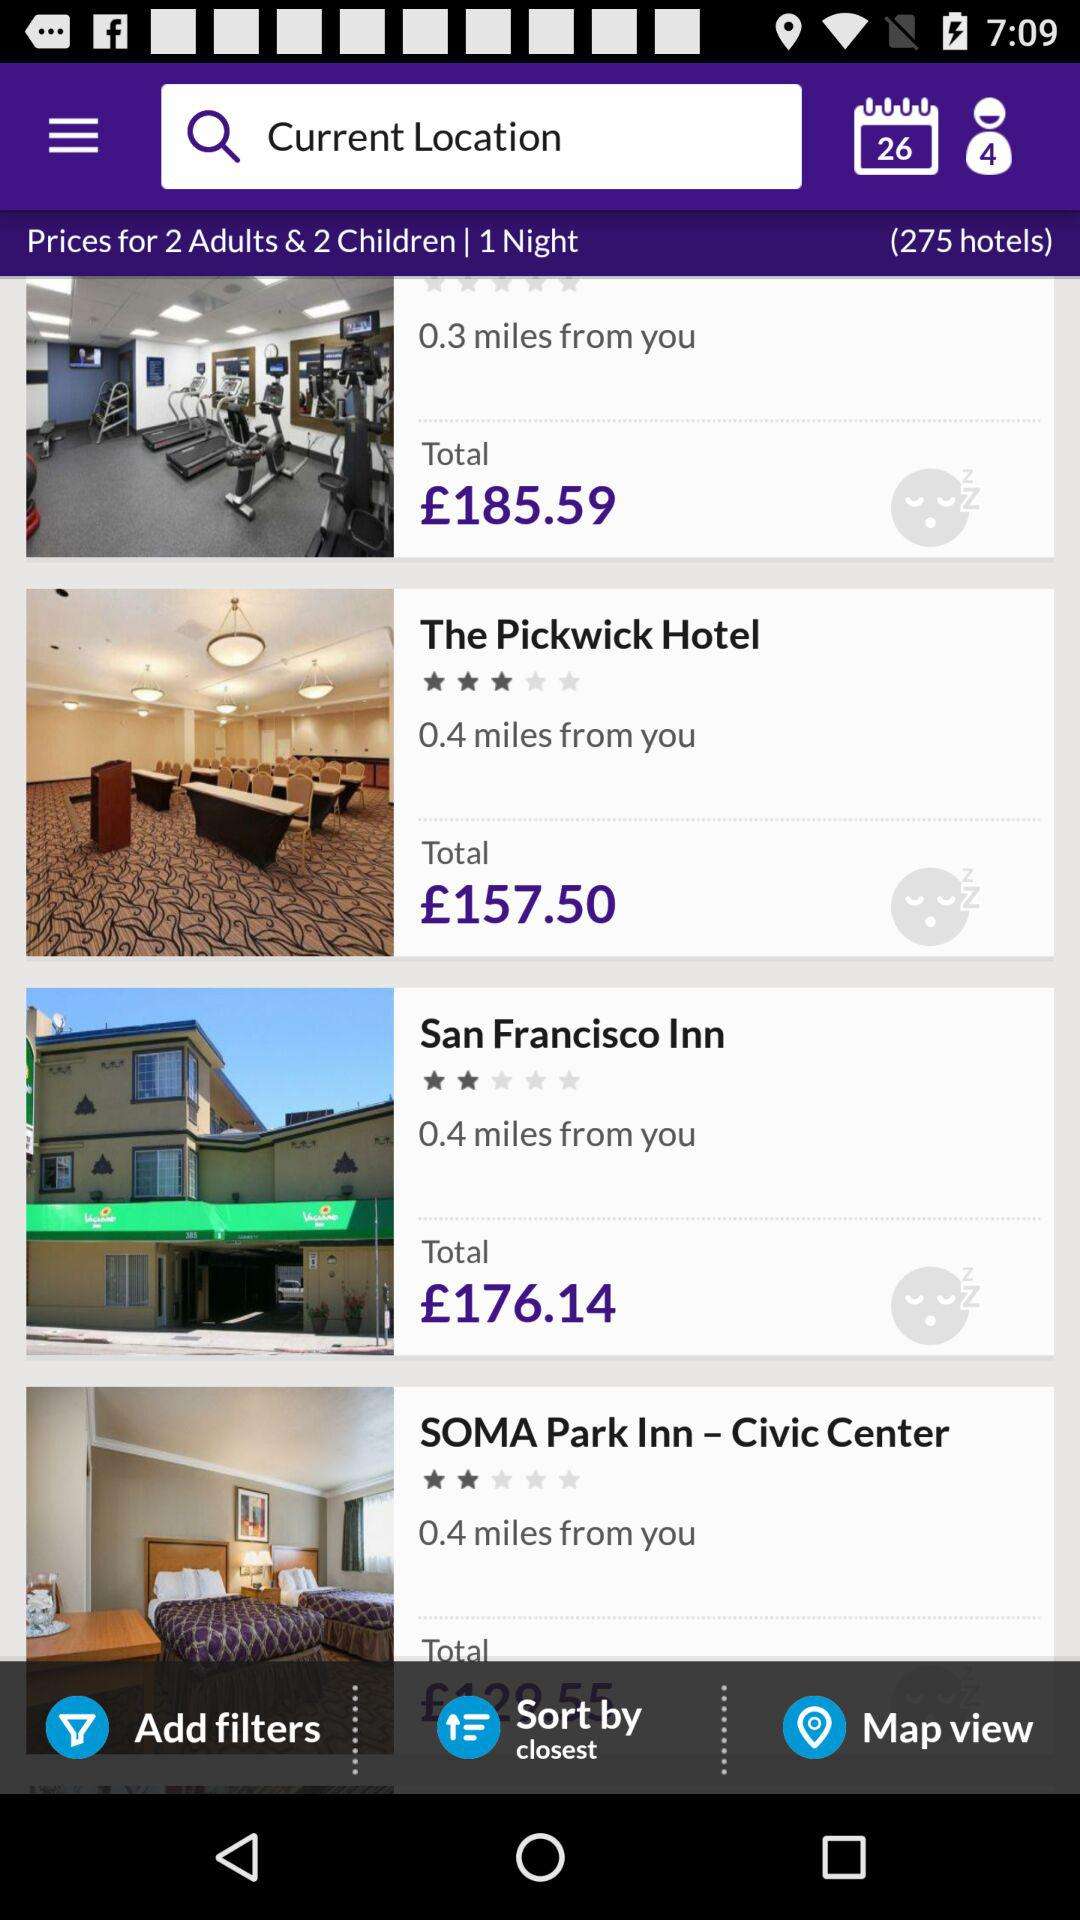How many hotels are there?
Answer the question using a single word or phrase. 275 